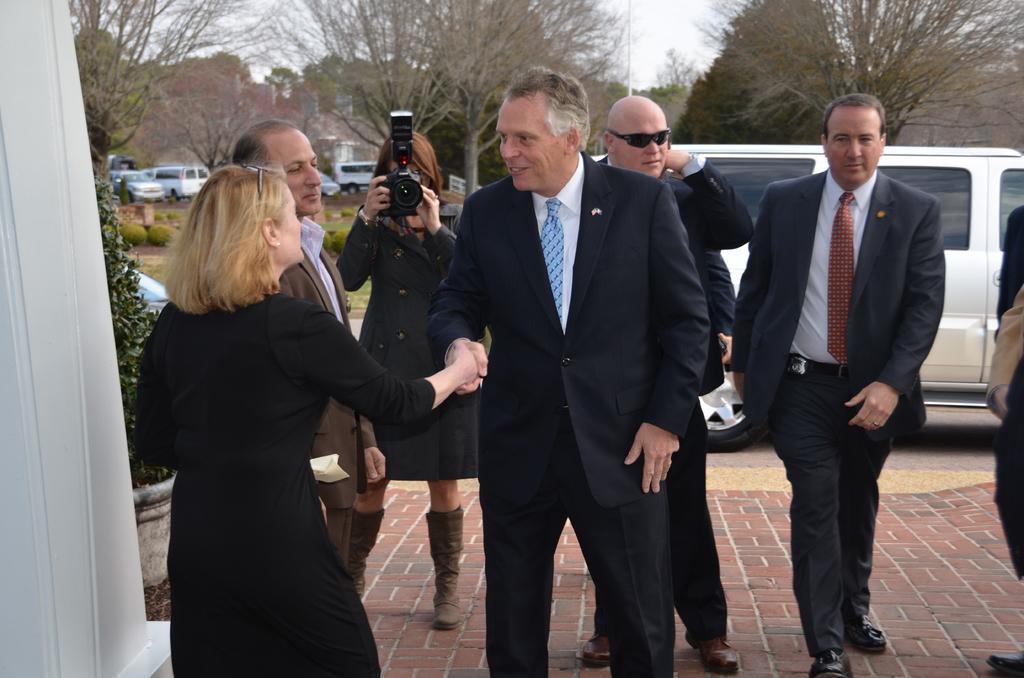Can you describe this image briefly? In the image i can see the persons wearing the black jackets. Behind them there is the person taking the picture of them and i can also in the background there are trees,mountains,cars,grass and the sky. 